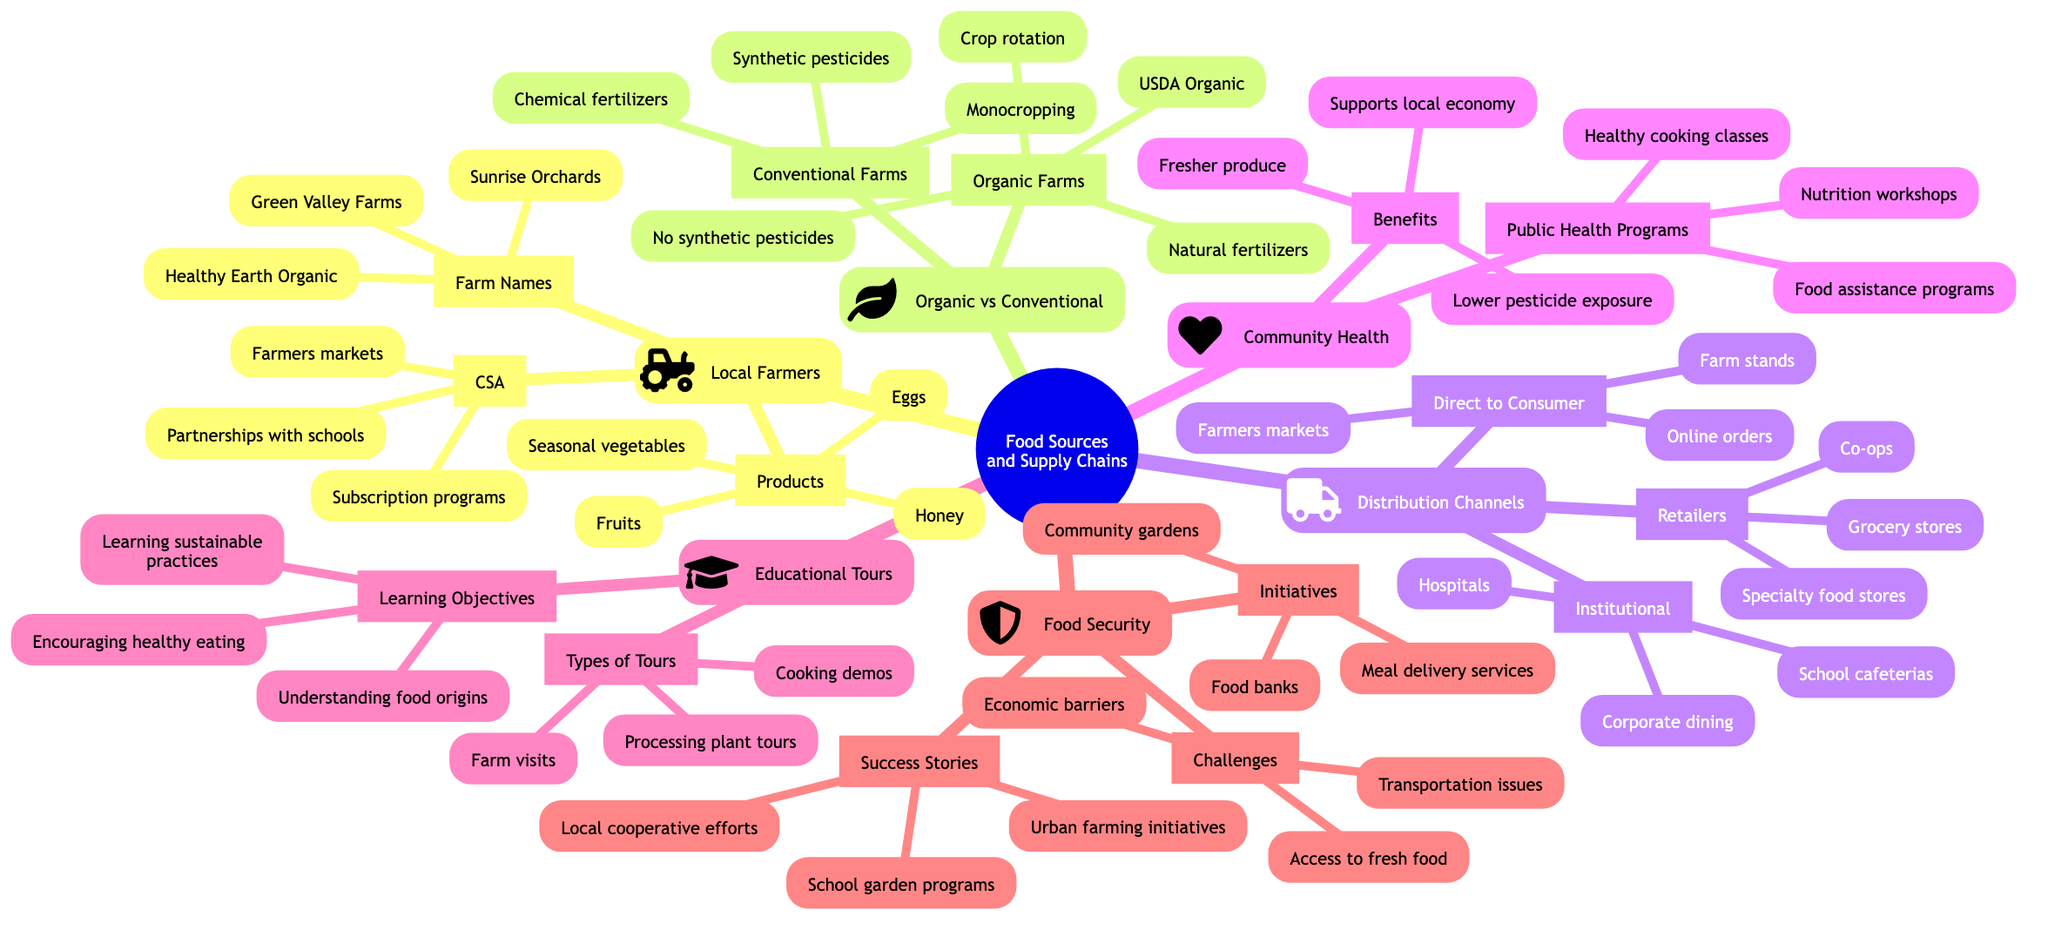What are the names of three local farms? The diagram lists three local farms under "Local Farmers." They are explicitly mentioned as "Green Valley Farms," "Sunrise Orchards," and "Healthy Earth Organic."
Answer: Green Valley Farms, Sunrise Orchards, Healthy Earth Organic What are two types of food distribution channels? The categories "Distribution Channels" includes three subcategories: "Direct to Consumer," "Retailers," and "Institutional." Any two types listed under these categories (e.g., Farmers markets and Grocery stores) would be correct answers.
Answer: Farmers markets, Grocery stores How many practices are listed for organic farms? Under "Organic Farms," there are three practices mentioned: "No synthetic pesticides," "Natural fertilizers," and "Crop rotation." Therefore, the count is three.
Answer: 3 What is one challenge faced by conventional farms? The diagram indicates one specific challenge under "Conventional Farms" as "Soil degradation," but also mentions "Water contamination." Hence, any one of these challenges is a valid answer.
Answer: Soil degradation What are two benefits of local and organic farming? The section "Benefits of Local and Organic Farming" lists three benefits: "Fresher produce," "Lower pesticide exposure," and "Supports local economy." Any two of these would qualify as an answer.
Answer: Fresher produce, Lower pesticide exposure How many types of educational tours are mentioned? In the "Educational Tours" section, it specifies three types of tours: "Farm visits," "Processing plant tours," and "Cooking demos." Thus, the total is three.
Answer: 3 Which initiative is aimed at improving food security? Within "Food Security," an initiative called "Community gardens" is listed. This is aimed at enhancing food security, among others.
Answer: Community gardens What is a public health program listed in the diagram? The diagram includes "Nutrition workshops," "Healthy cooking classes," and "Food assistance programs" under "Public Health Programs." Selecting any one of these is a valid answer.
Answer: Nutrition workshops What kind of farms does the USDA certify? The diagram specifies that the "Organic Farms" are certified as "USDA Organic," indicating that they meet the necessary standards defined by the USDA.
Answer: USDA Organic 